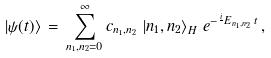Convert formula to latex. <formula><loc_0><loc_0><loc_500><loc_500>\left | \psi ( t ) \right > \, = \, \sum _ { n _ { 1 } , n _ { 2 } = 0 } ^ { \infty } c _ { n _ { 1 } , n _ { 2 } } \, \left | n _ { 1 } , n _ { 2 } \right > _ { H } \, e ^ { - \frac { i } { } E _ { n _ { 1 } , n _ { 2 } } \, t } \, ,</formula> 